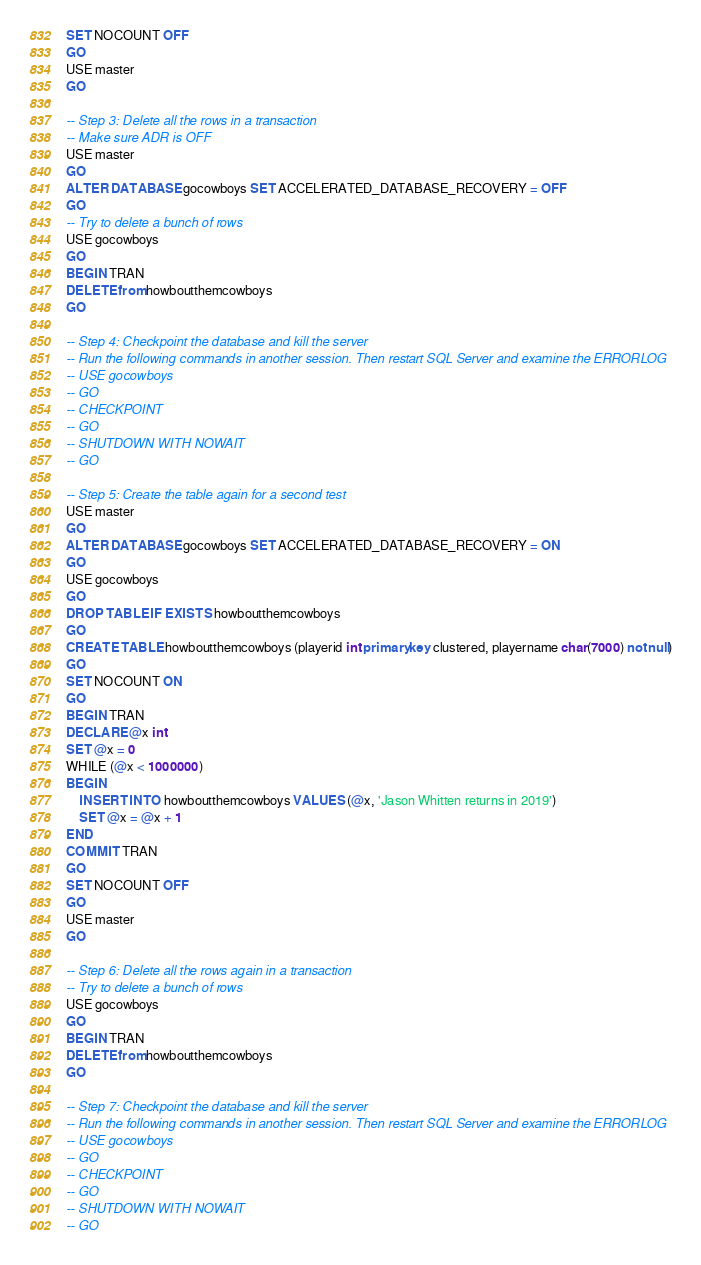Convert code to text. <code><loc_0><loc_0><loc_500><loc_500><_SQL_>SET NOCOUNT OFF
GO
USE master
GO

-- Step 3: Delete all the rows in a transaction
-- Make sure ADR is OFF
USE master
GO
ALTER DATABASE gocowboys SET ACCELERATED_DATABASE_RECOVERY = OFF
GO
-- Try to delete a bunch of rows
USE gocowboys
GO
BEGIN TRAN
DELETE from howboutthemcowboys
GO

-- Step 4: Checkpoint the database and kill the server
-- Run the following commands in another session. Then restart SQL Server and examine the ERRORLOG
-- USE gocowboys
-- GO
-- CHECKPOINT
-- GO
-- SHUTDOWN WITH NOWAIT
-- GO

-- Step 5: Create the table again for a second test
USE master
GO
ALTER DATABASE gocowboys SET ACCELERATED_DATABASE_RECOVERY = ON
GO
USE gocowboys
GO
DROP TABLE IF EXISTS howboutthemcowboys
GO
CREATE TABLE howboutthemcowboys (playerid int primary key clustered, playername char(7000) not null)
GO
SET NOCOUNT ON
GO
BEGIN TRAN
DECLARE @x int
SET @x = 0
WHILE (@x < 1000000)
BEGIN
	INSERT INTO howboutthemcowboys VALUES (@x, 'Jason Whitten returns in 2019')
	SET @x = @x + 1
END
COMMIT TRAN
GO
SET NOCOUNT OFF
GO
USE master
GO

-- Step 6: Delete all the rows again in a transaction
-- Try to delete a bunch of rows
USE gocowboys
GO
BEGIN TRAN
DELETE from howboutthemcowboys
GO

-- Step 7: Checkpoint the database and kill the server
-- Run the following commands in another session. Then restart SQL Server and examine the ERRORLOG
-- USE gocowboys
-- GO
-- CHECKPOINT
-- GO
-- SHUTDOWN WITH NOWAIT
-- GO
</code> 